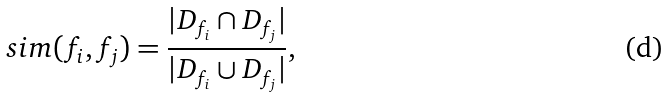Convert formula to latex. <formula><loc_0><loc_0><loc_500><loc_500>s i m ( f _ { i } , f _ { j } ) = \frac { | D _ { f _ { i } } \cap D _ { f _ { j } } | } { | D _ { f _ { i } } \cup D _ { f _ { j } } | } ,</formula> 